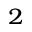<formula> <loc_0><loc_0><loc_500><loc_500>^ { 2 }</formula> 